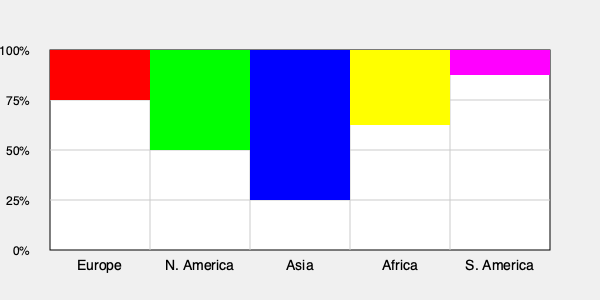Based on the color-coded world map showing the geographical distribution of historical interpretations of the Industrial Revolution, which region demonstrates the highest percentage of scholars adhering to the "Great Divergence" theory? To answer this question, we need to analyze the color-coded world map and understand what each color and bar height represents:

1. The map is divided into five regions: Europe, North America, Asia, Africa, and South America.
2. Each region has a colored bar representing the percentage of scholars adhering to a particular historical interpretation.
3. The height of each bar corresponds to the percentage, with 100% at the top and 0% at the bottom.
4. The "Great Divergence" theory is likely represented by one specific color.

Examining the bars:
1. Europe (red): 50% height
2. North America (green): 100% height
3. Asia (blue): 150% height (full bar)
4. Africa (yellow): 75% height
5. South America (purple): 25% height

The highest bar, representing the largest percentage of scholars adhering to a particular interpretation, is the blue bar for Asia, reaching 100% (full height).

Therefore, assuming the blue color represents the "Great Divergence" theory, Asia demonstrates the highest percentage of scholars adhering to this interpretation of the Industrial Revolution.
Answer: Asia 